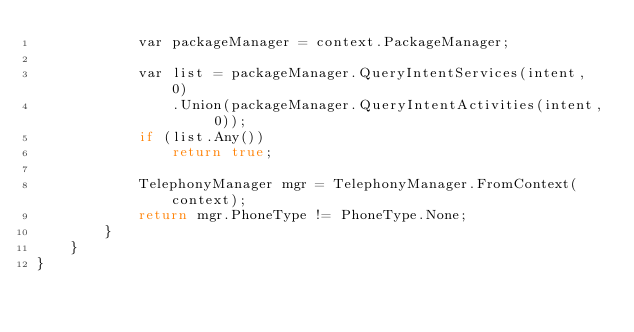Convert code to text. <code><loc_0><loc_0><loc_500><loc_500><_C#_>			var packageManager = context.PackageManager;
			
			var list = packageManager.QueryIntentServices(intent, 0)
				.Union(packageManager.QueryIntentActivities(intent, 0));
			if (list.Any())
				return true;
			
			TelephonyManager mgr = TelephonyManager.FromContext(context);
			return mgr.PhoneType != PhoneType.None;
		}
	}
}
</code> 